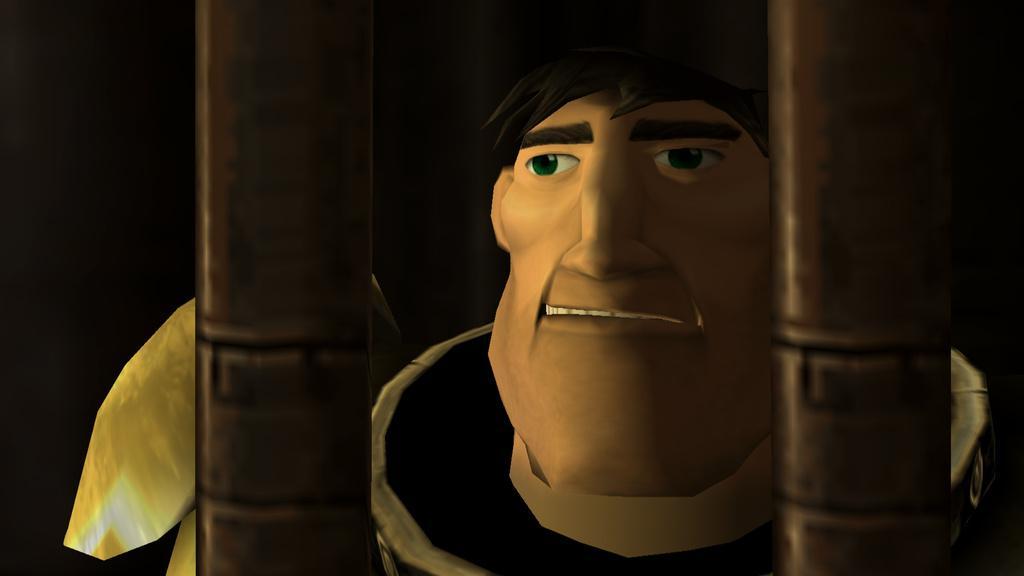How would you summarize this image in a sentence or two? Here this is an animated image, in which we can see a man in an Armour present over a place and in front of it we can see some kind of moles present. 